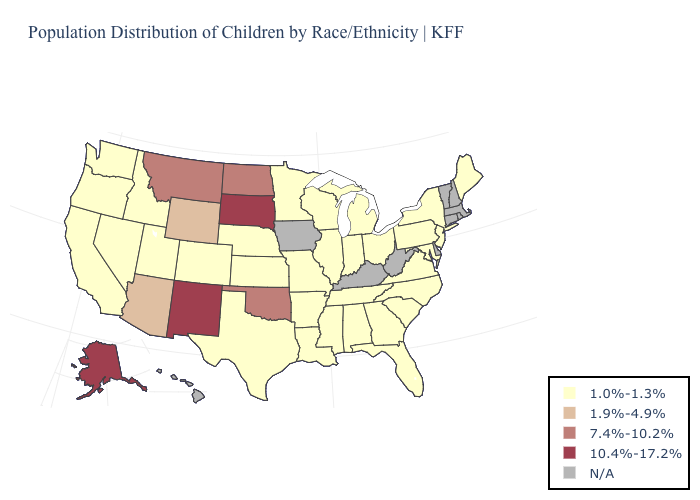Which states have the lowest value in the MidWest?
Write a very short answer. Illinois, Indiana, Kansas, Michigan, Minnesota, Missouri, Nebraska, Ohio, Wisconsin. Is the legend a continuous bar?
Answer briefly. No. Does the map have missing data?
Short answer required. Yes. What is the lowest value in states that border Arkansas?
Short answer required. 1.0%-1.3%. What is the highest value in states that border Kentucky?
Keep it brief. 1.0%-1.3%. Which states have the lowest value in the USA?
Give a very brief answer. Alabama, Arkansas, California, Colorado, Florida, Georgia, Idaho, Illinois, Indiana, Kansas, Louisiana, Maine, Maryland, Michigan, Minnesota, Mississippi, Missouri, Nebraska, Nevada, New Jersey, New York, North Carolina, Ohio, Oregon, Pennsylvania, South Carolina, Tennessee, Texas, Utah, Virginia, Washington, Wisconsin. What is the value of New Mexico?
Keep it brief. 10.4%-17.2%. Is the legend a continuous bar?
Be succinct. No. Does South Dakota have the highest value in the USA?
Give a very brief answer. Yes. What is the value of Rhode Island?
Concise answer only. N/A. What is the value of Michigan?
Short answer required. 1.0%-1.3%. What is the value of Indiana?
Quick response, please. 1.0%-1.3%. 